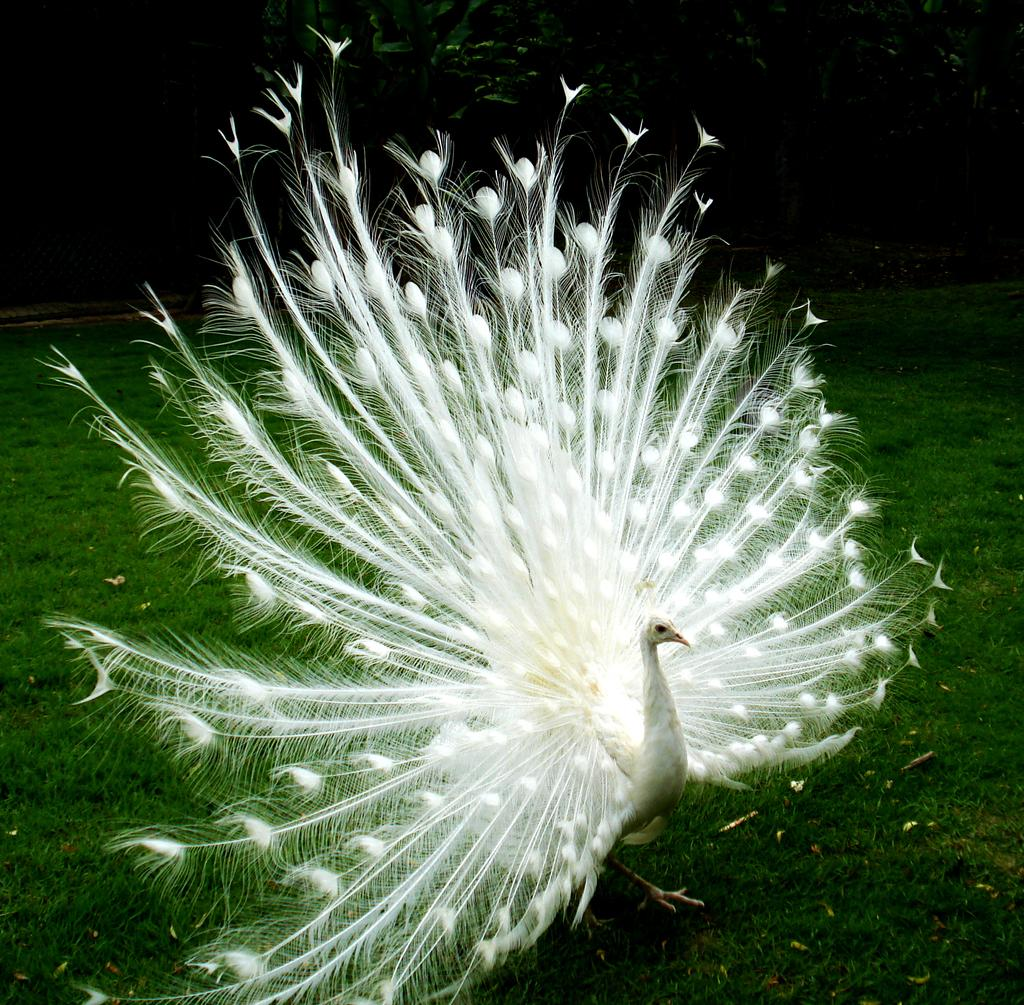What animal is the main subject of the image? There is a peacock in the image. What is the peacock doing in the image? The peacock is standing. What type of terrain is visible at the bottom of the image? There is grass at the bottom of the image. What can be seen in the background of the image? There are trees in the background of the image. What feature of the peacock is visible in the middle of the image? The peacock's train is visible in the middle of the image. What type of sign is the peacock holding in the image? There is no sign present in the image; the peacock is not holding anything. Can you tell me the name of the governor who is standing next to the peacock in the image? There is no governor present in the image; it only features a peacock. 